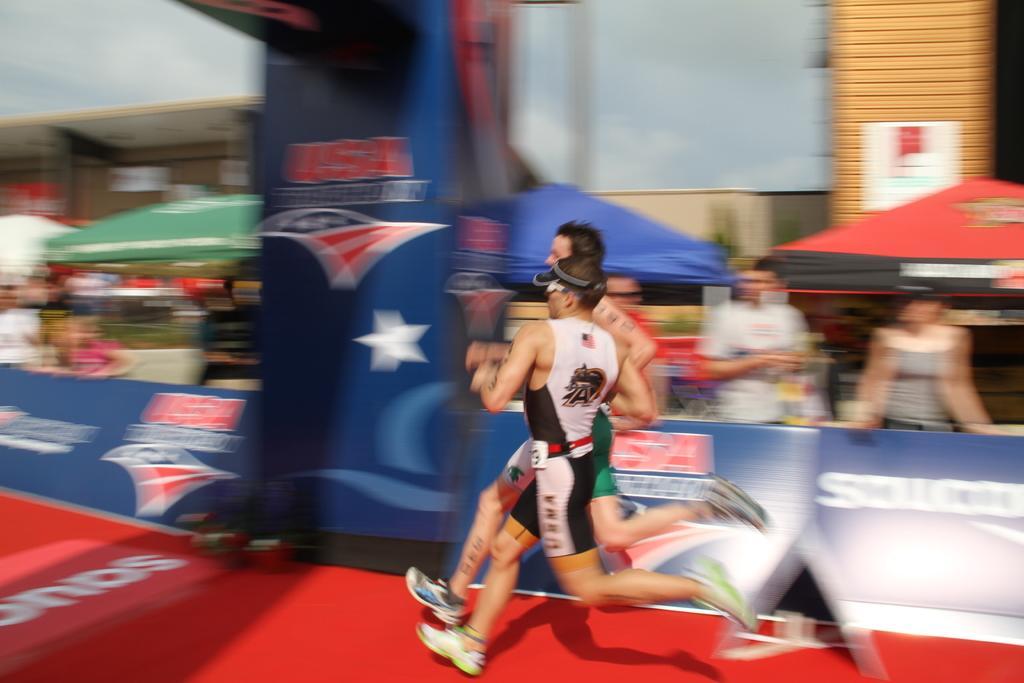Could you give a brief overview of what you see in this image? It is a blur image there are two athletes running on a red surface, the picture is taken while they are running, around them there are people and banners. 